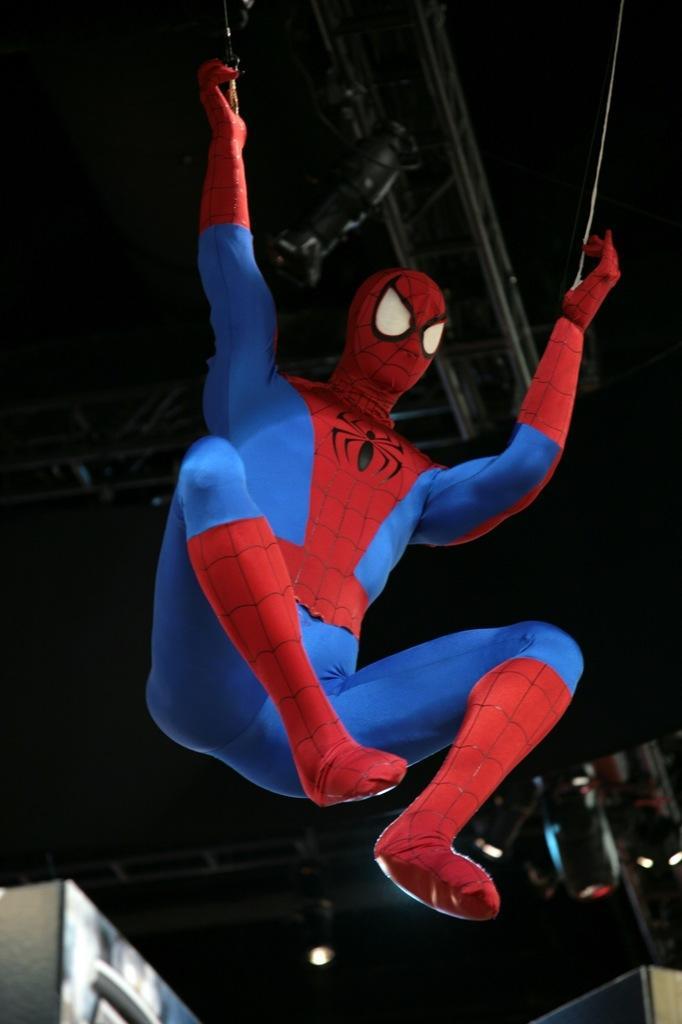Describe this image in one or two sentences. In this image, we can see a spider man on the black background. 